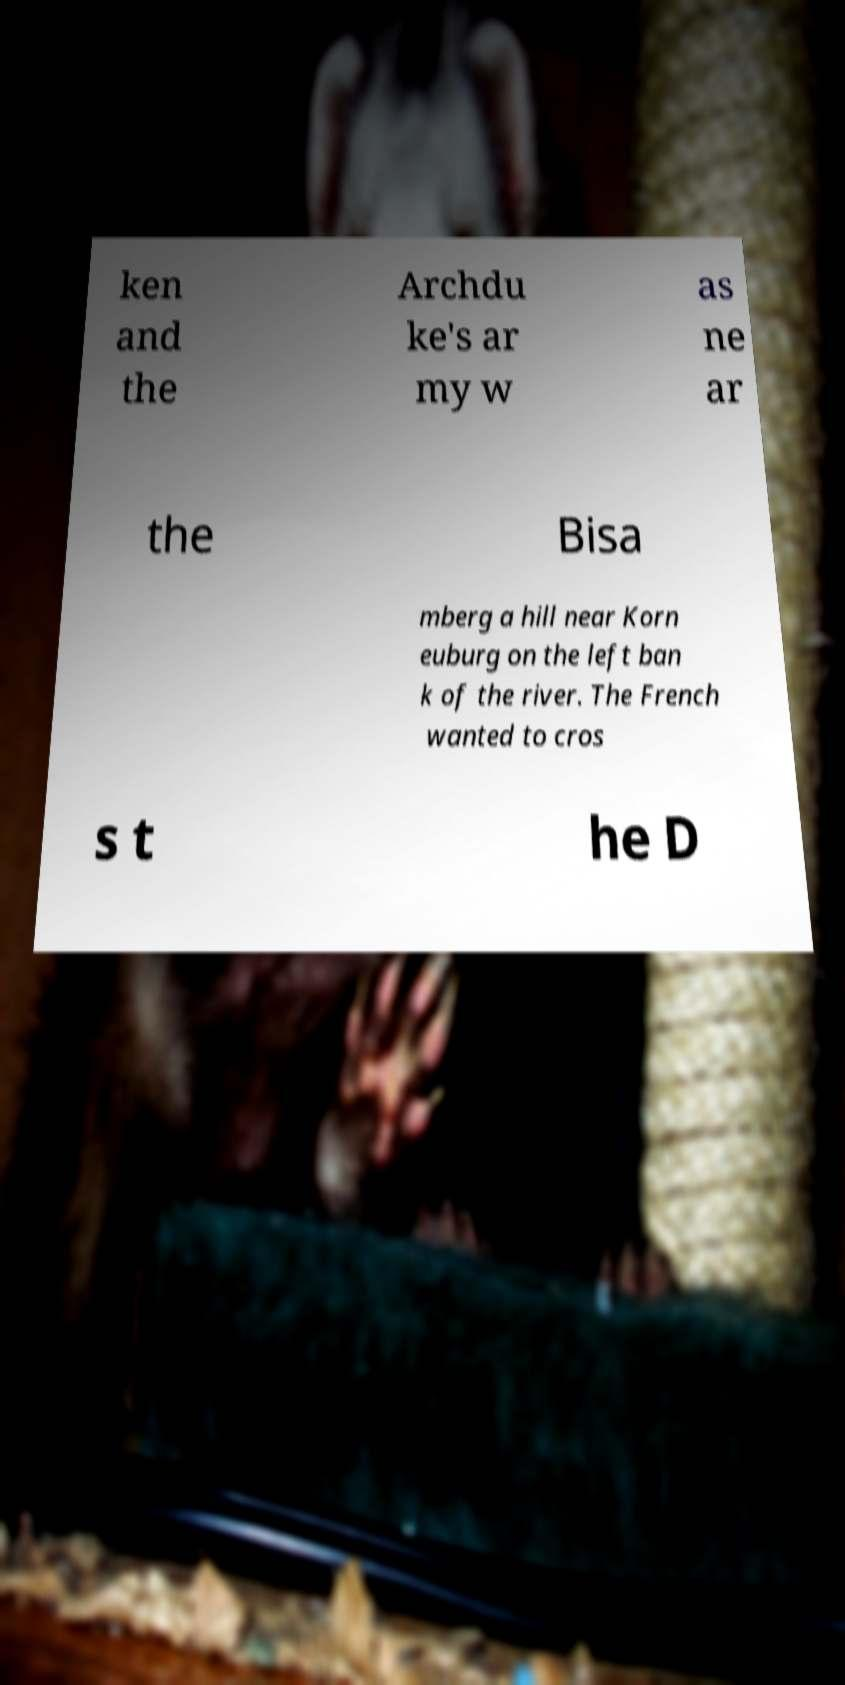Can you accurately transcribe the text from the provided image for me? ken and the Archdu ke's ar my w as ne ar the Bisa mberg a hill near Korn euburg on the left ban k of the river. The French wanted to cros s t he D 